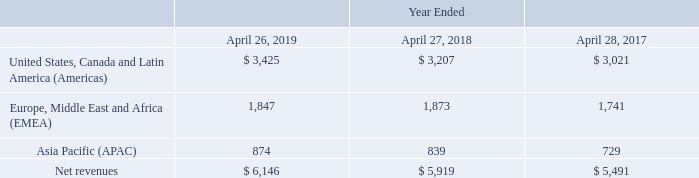16. Segment, Geographic, and Significant Customer Information
We operate in one industry segment: the design, manufacturing, marketing, and technical support of high-performance storage and data management solutions. We conduct business globally, and our sales and support activities are managed on a geographic basis. Our management reviews financial information presented on a consolidated basis, accompanied by disaggregated information it receives from our internal management system about revenues by geographic region, based on the location from which the customer relationship is managed, for purposes of allocating resources and evaluating financial performance. We do not allocate costs of revenues, research and development, sales and marketing, or general and administrative expenses to our geographic regions in this internal management reporting because management does not review operations or operating results, or make planning decisions, below the consolidated entity level.
Summarized revenues by geographic region based on information from our internal management system and utilized by our Chief Executive Officer, who is considered our Chief Operating Decision Maker, is as follows (in millions):
Americas revenues consist of sales to Americas commercial and U.S. public sector markets. Sales to customers inside the U.S. were $3,116 million, $2,878 million and $2,721 million during fiscal 2019, 2018 and 2017, respectively.
What was the sales to customers inside the U.S. in 2017? $2,721 million. Which years does the table provide information for Summarized revenues by geographic region? 2019, 2018, 2017. Which industry segment does the company operate in? The design, manufacturing, marketing, and technical support of high-performance storage and data management solutions. What was the change in the revenue from Asia Pacific between 2017 and 2018?
Answer scale should be: million. 839-729
Answer: 110. How many years did revenue from the Americas exceed $3,000 million? 2019##2018##2017
Answer: 3. What was the percentage change in net revenues between 2018 and 2019?
Answer scale should be: percent. (6,146-5,919)/5,919
Answer: 3.84. 